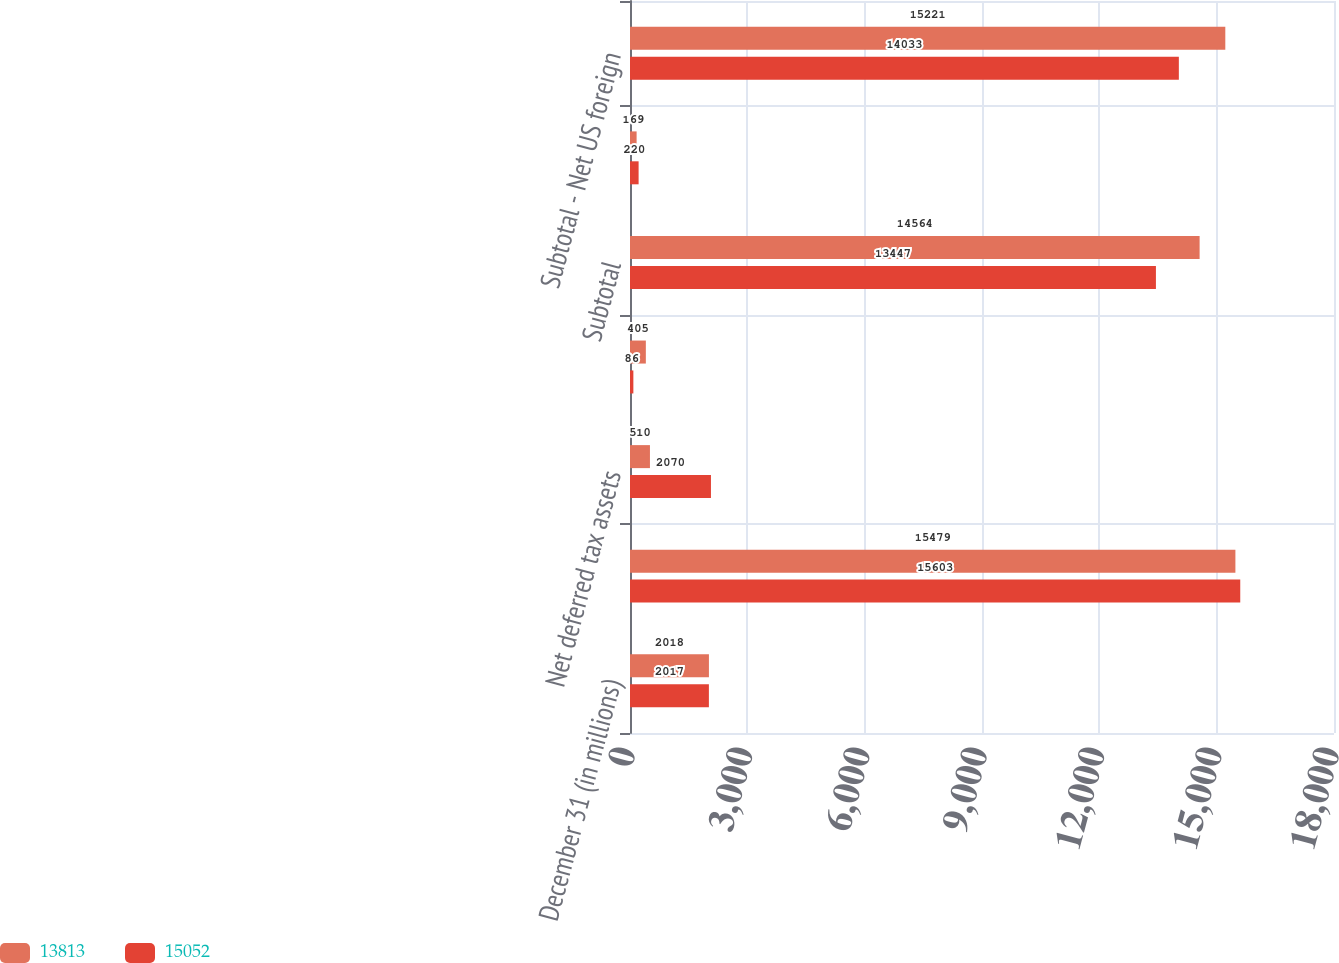<chart> <loc_0><loc_0><loc_500><loc_500><stacked_bar_chart><ecel><fcel>December 31 (in millions)<fcel>Net US consolidated return<fcel>Net deferred tax assets<fcel>Valuation allowance<fcel>Subtotal<fcel>Net foreign state and local<fcel>Subtotal - Net US foreign<nl><fcel>13813<fcel>2018<fcel>15479<fcel>510<fcel>405<fcel>14564<fcel>169<fcel>15221<nl><fcel>15052<fcel>2017<fcel>15603<fcel>2070<fcel>86<fcel>13447<fcel>220<fcel>14033<nl></chart> 